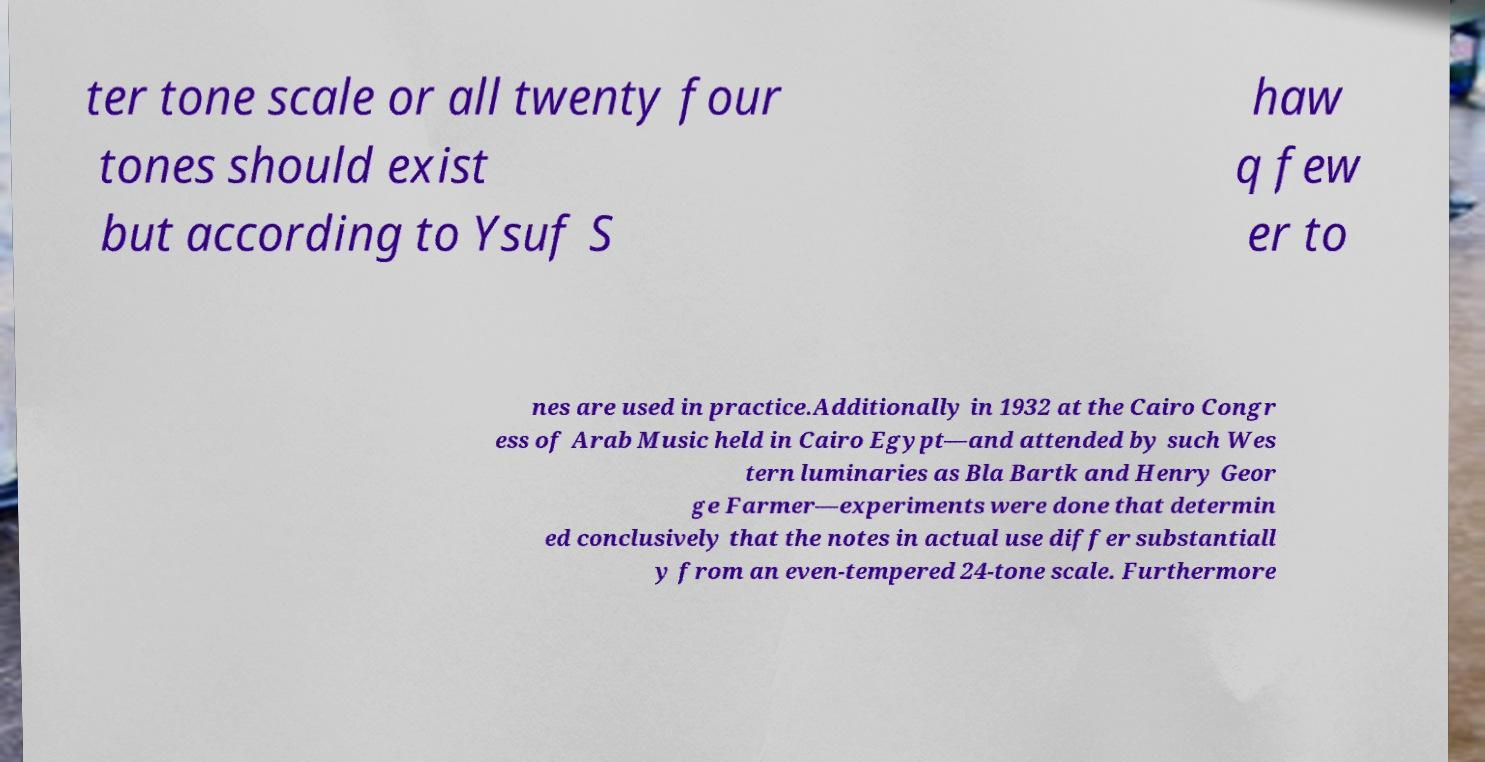Please identify and transcribe the text found in this image. ter tone scale or all twenty four tones should exist but according to Ysuf S haw q few er to nes are used in practice.Additionally in 1932 at the Cairo Congr ess of Arab Music held in Cairo Egypt—and attended by such Wes tern luminaries as Bla Bartk and Henry Geor ge Farmer—experiments were done that determin ed conclusively that the notes in actual use differ substantiall y from an even-tempered 24-tone scale. Furthermore 